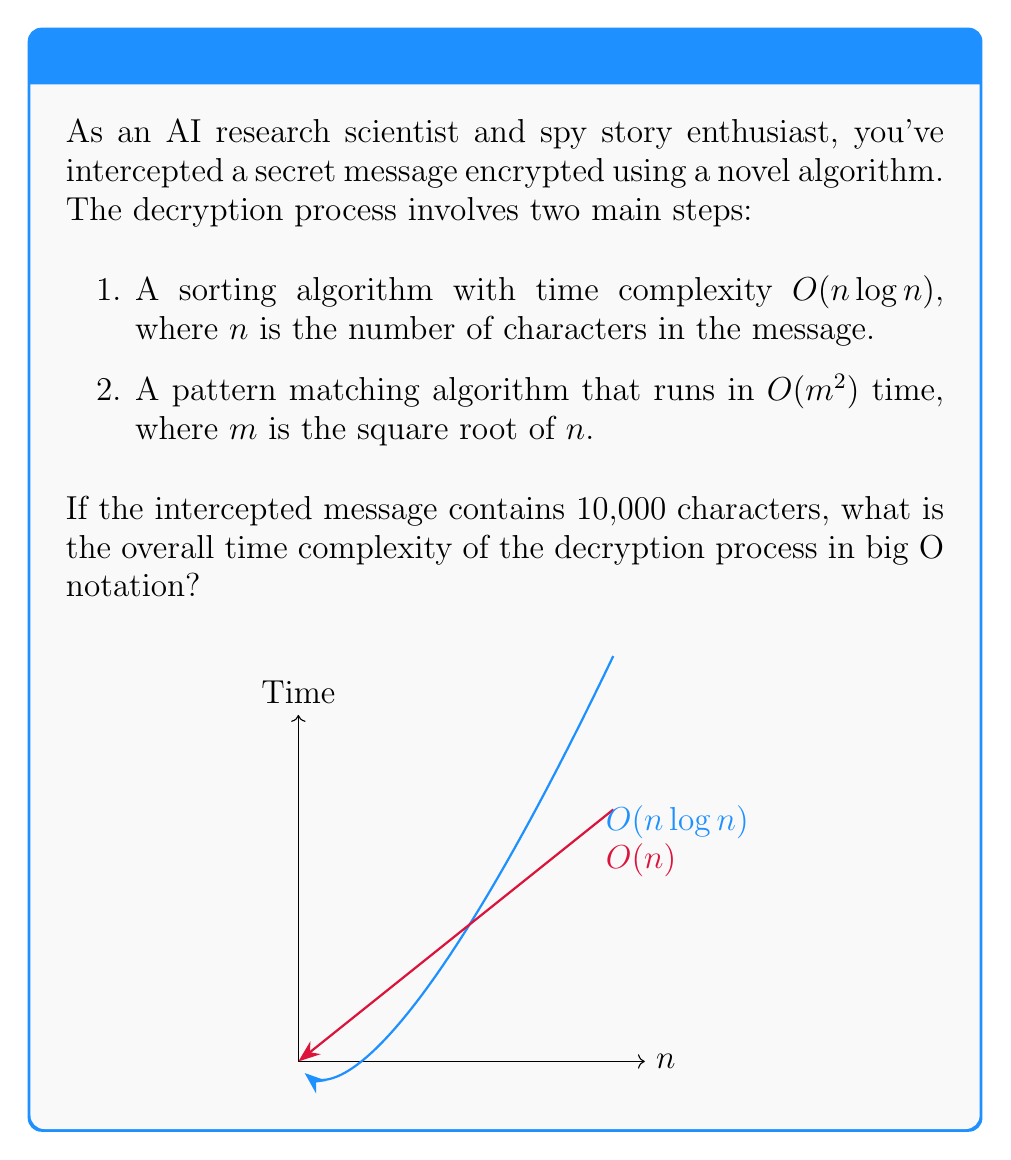Solve this math problem. Let's approach this step-by-step:

1) First, we need to understand the given information:
   - The message has $n = 10,000$ characters
   - Step 1 has complexity $O(n \log n)$
   - Step 2 has complexity $O(m^2)$, where $m = \sqrt{n}$

2) Let's calculate $m$:
   $m = \sqrt{n} = \sqrt{10,000} = 100$

3) Now, let's express the complexity of each step in terms of $n$:
   - Step 1: $O(n \log n)$
   - Step 2: $O(m^2) = O((\sqrt{n})^2) = O(n)$

4) To find the overall complexity, we need to add these together:
   $O(n \log n + n)$

5) In big O notation, we only keep the dominant term. To determine which term is dominant, we can compare them:
   $n \log n$ grows faster than $n$ for large $n$

6) Therefore, we can simplify the expression to:
   $O(n \log n)$

7) This is our final answer, as it represents the overall time complexity of the decryption process.
Answer: $O(n \log n)$ 